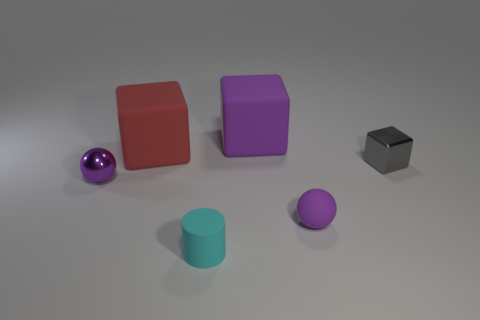There is a rubber thing that is in front of the small purple thing in front of the small purple thing behind the matte ball; what color is it?
Provide a short and direct response. Cyan. What shape is the small thing that is both left of the matte ball and behind the small cyan matte cylinder?
Offer a very short reply. Sphere. What number of other things are there of the same shape as the gray object?
Provide a short and direct response. 2. There is a tiny metallic object on the right side of the small thing on the left side of the cyan matte cylinder to the left of the big purple matte cube; what is its shape?
Your answer should be very brief. Cube. What number of objects are metallic cubes or big purple rubber objects that are behind the tiny purple metallic ball?
Your response must be concise. 2. Do the big object that is behind the red rubber thing and the purple rubber thing in front of the large red rubber thing have the same shape?
Give a very brief answer. No. How many things are either big green metallic cylinders or tiny purple matte spheres?
Provide a succinct answer. 1. Is there any other thing that is the same material as the small cyan object?
Ensure brevity in your answer.  Yes. Are there any shiny spheres?
Provide a succinct answer. Yes. Is the purple ball in front of the purple shiny sphere made of the same material as the large red block?
Your response must be concise. Yes. 